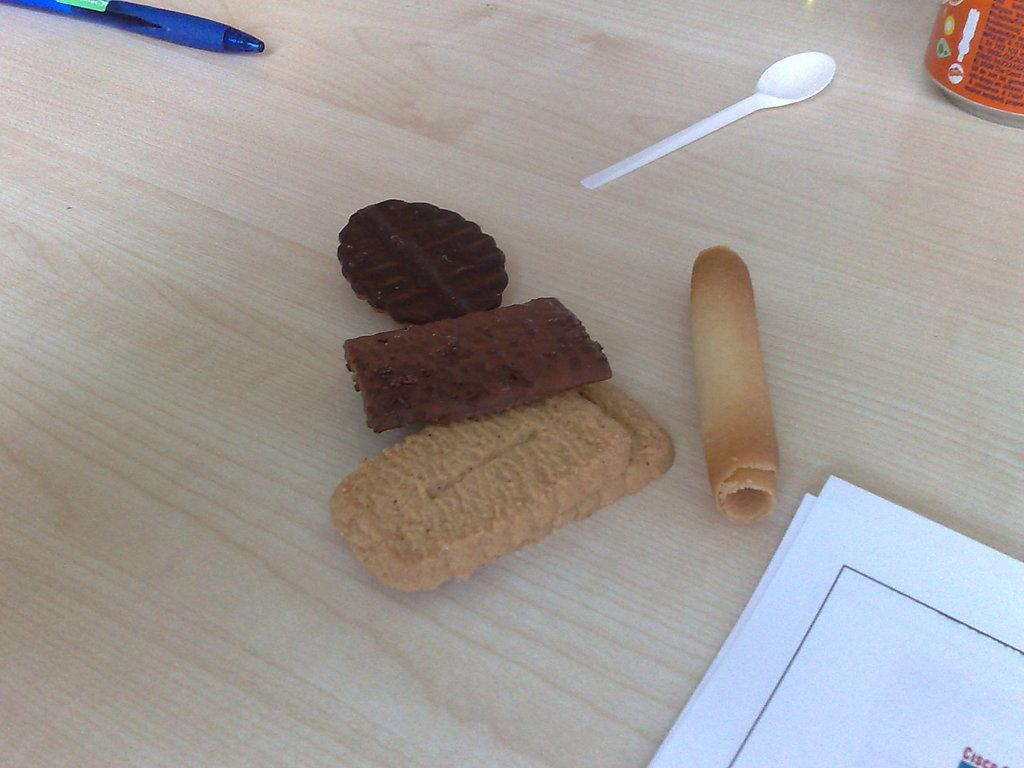What type of food can be seen on the table in the image? There are biscuits on the table in the image. What can be found in the right corner of the image? There are papers and a tin in the right corner of the image. What utensil is present on the table? There is a spoon on the table. What stationery item is visible in the left corner of the image? There is a pen in the left corner of the image. What language is being spoken by the cough in the image? There is no cough present in the image, and therefore no language can be associated with it. What type of border is visible in the image? There is no border visible in the image; it features biscuits, papers, a tin, a spoon, and a pen. 